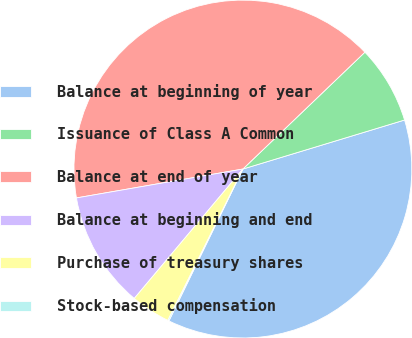Convert chart to OTSL. <chart><loc_0><loc_0><loc_500><loc_500><pie_chart><fcel>Balance at beginning of year<fcel>Issuance of Class A Common<fcel>Balance at end of year<fcel>Balance at beginning and end<fcel>Purchase of treasury shares<fcel>Stock-based compensation<nl><fcel>36.9%<fcel>7.47%<fcel>40.58%<fcel>11.15%<fcel>3.79%<fcel>0.11%<nl></chart> 